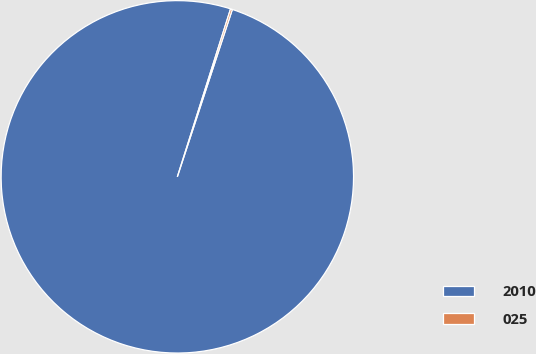<chart> <loc_0><loc_0><loc_500><loc_500><pie_chart><fcel>2010<fcel>025<nl><fcel>99.83%<fcel>0.17%<nl></chart> 